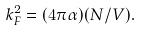<formula> <loc_0><loc_0><loc_500><loc_500>k _ { F } ^ { 2 } = ( 4 \pi \alpha ) ( N / V ) .</formula> 